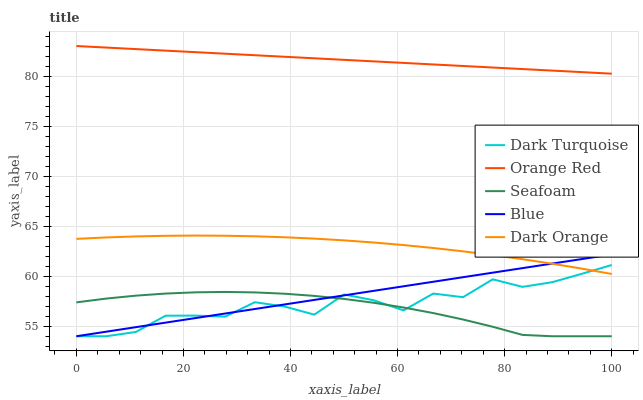Does Seafoam have the minimum area under the curve?
Answer yes or no. Yes. Does Orange Red have the maximum area under the curve?
Answer yes or no. Yes. Does Dark Turquoise have the minimum area under the curve?
Answer yes or no. No. Does Dark Turquoise have the maximum area under the curve?
Answer yes or no. No. Is Blue the smoothest?
Answer yes or no. Yes. Is Dark Turquoise the roughest?
Answer yes or no. Yes. Is Orange Red the smoothest?
Answer yes or no. No. Is Orange Red the roughest?
Answer yes or no. No. Does Blue have the lowest value?
Answer yes or no. Yes. Does Orange Red have the lowest value?
Answer yes or no. No. Does Orange Red have the highest value?
Answer yes or no. Yes. Does Dark Turquoise have the highest value?
Answer yes or no. No. Is Blue less than Orange Red?
Answer yes or no. Yes. Is Orange Red greater than Dark Turquoise?
Answer yes or no. Yes. Does Seafoam intersect Blue?
Answer yes or no. Yes. Is Seafoam less than Blue?
Answer yes or no. No. Is Seafoam greater than Blue?
Answer yes or no. No. Does Blue intersect Orange Red?
Answer yes or no. No. 